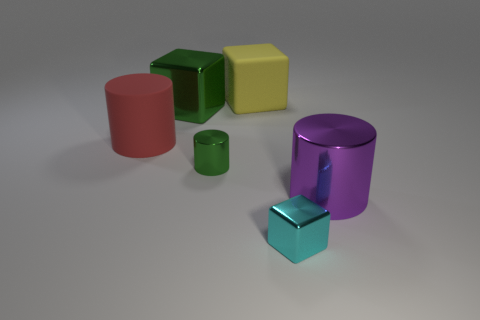What is the shape of the big purple object that is made of the same material as the green cylinder?
Ensure brevity in your answer.  Cylinder. What number of brown things are tiny shiny things or blocks?
Your answer should be very brief. 0. Are there any objects on the left side of the rubber thing to the left of the rubber cube that is behind the cyan shiny thing?
Offer a terse response. No. Is the number of green shiny cubes less than the number of big metal objects?
Offer a terse response. Yes. Does the big metallic thing on the left side of the large yellow matte cube have the same shape as the large yellow object?
Offer a terse response. Yes. Are there any large red matte cylinders?
Offer a very short reply. Yes. What color is the big cylinder on the right side of the metallic cube in front of the metallic thing to the right of the small block?
Your answer should be very brief. Purple. Are there an equal number of large red cylinders in front of the purple metal cylinder and large metal things that are behind the large red rubber cylinder?
Provide a succinct answer. No. The yellow rubber thing that is the same size as the red cylinder is what shape?
Make the answer very short. Cube. Is there a tiny metal object of the same color as the big metal block?
Offer a terse response. Yes. 